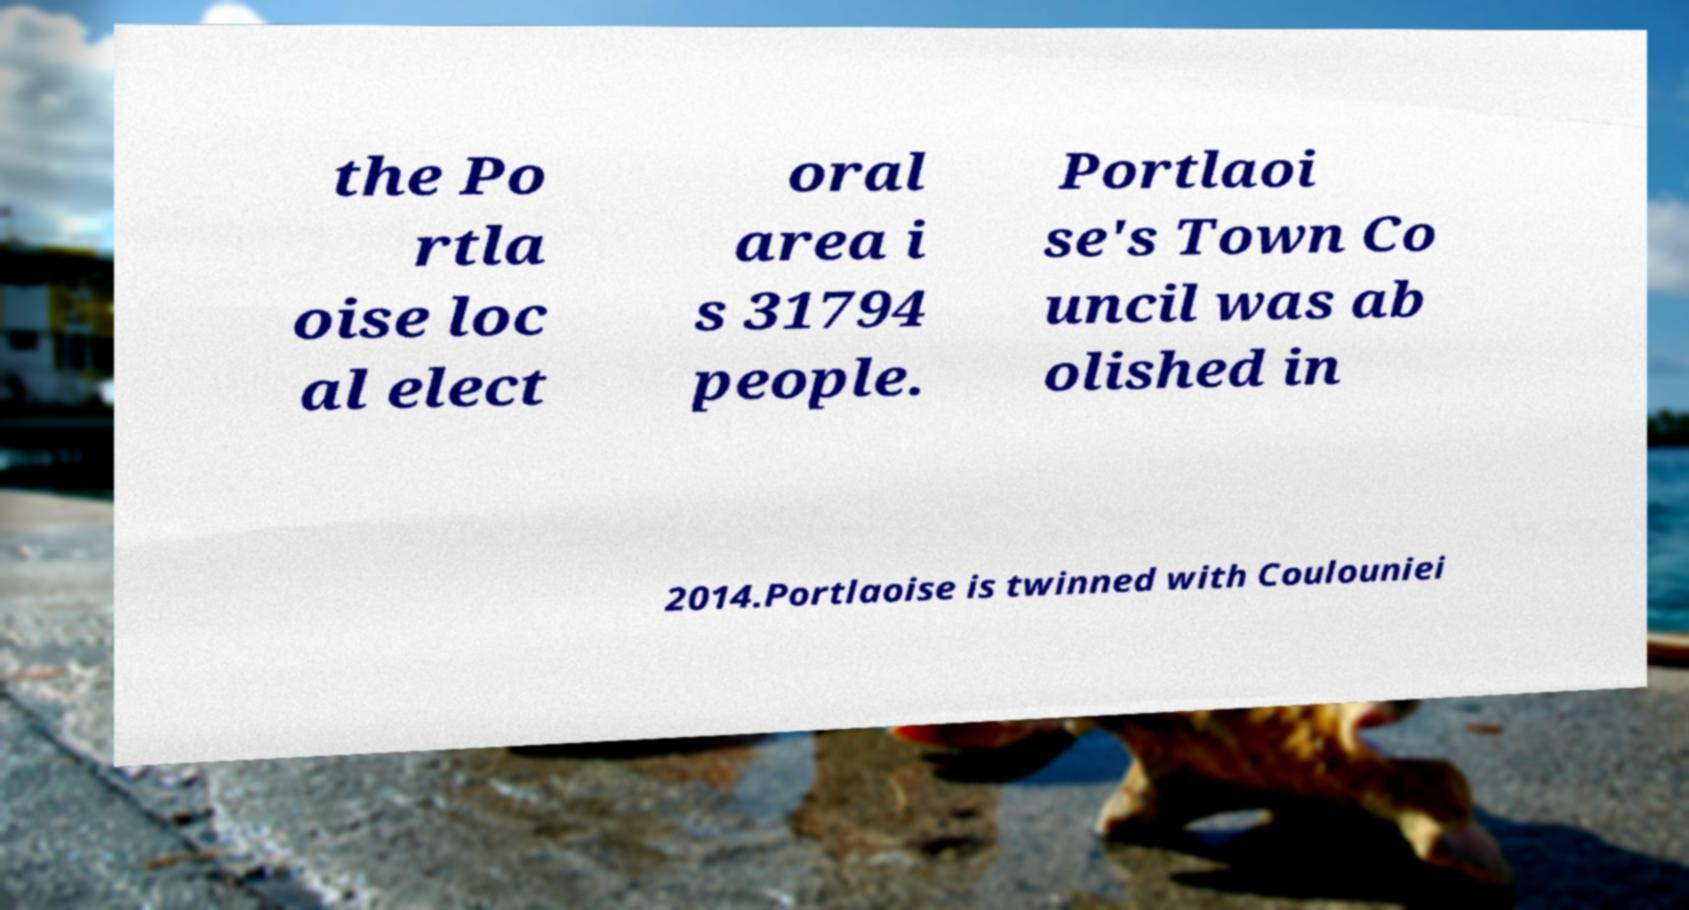Please read and relay the text visible in this image. What does it say? the Po rtla oise loc al elect oral area i s 31794 people. Portlaoi se's Town Co uncil was ab olished in 2014.Portlaoise is twinned with Coulouniei 